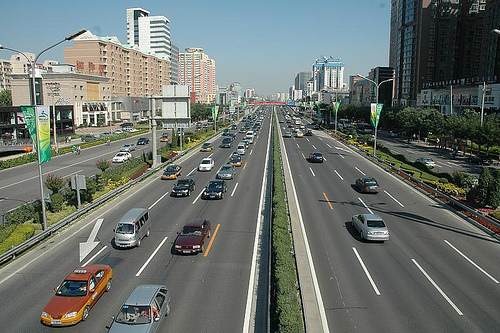<image>
Is there a sign behind the pole? No. The sign is not behind the pole. From this viewpoint, the sign appears to be positioned elsewhere in the scene. Is there a white car to the right of the sign? No. The white car is not to the right of the sign. The horizontal positioning shows a different relationship. Is the car in the road? No. The car is not contained within the road. These objects have a different spatial relationship. 